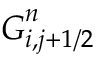<formula> <loc_0><loc_0><loc_500><loc_500>G _ { i , j + 1 / 2 } ^ { n }</formula> 